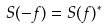<formula> <loc_0><loc_0><loc_500><loc_500>S ( - f ) = S ( f ) ^ { * }</formula> 